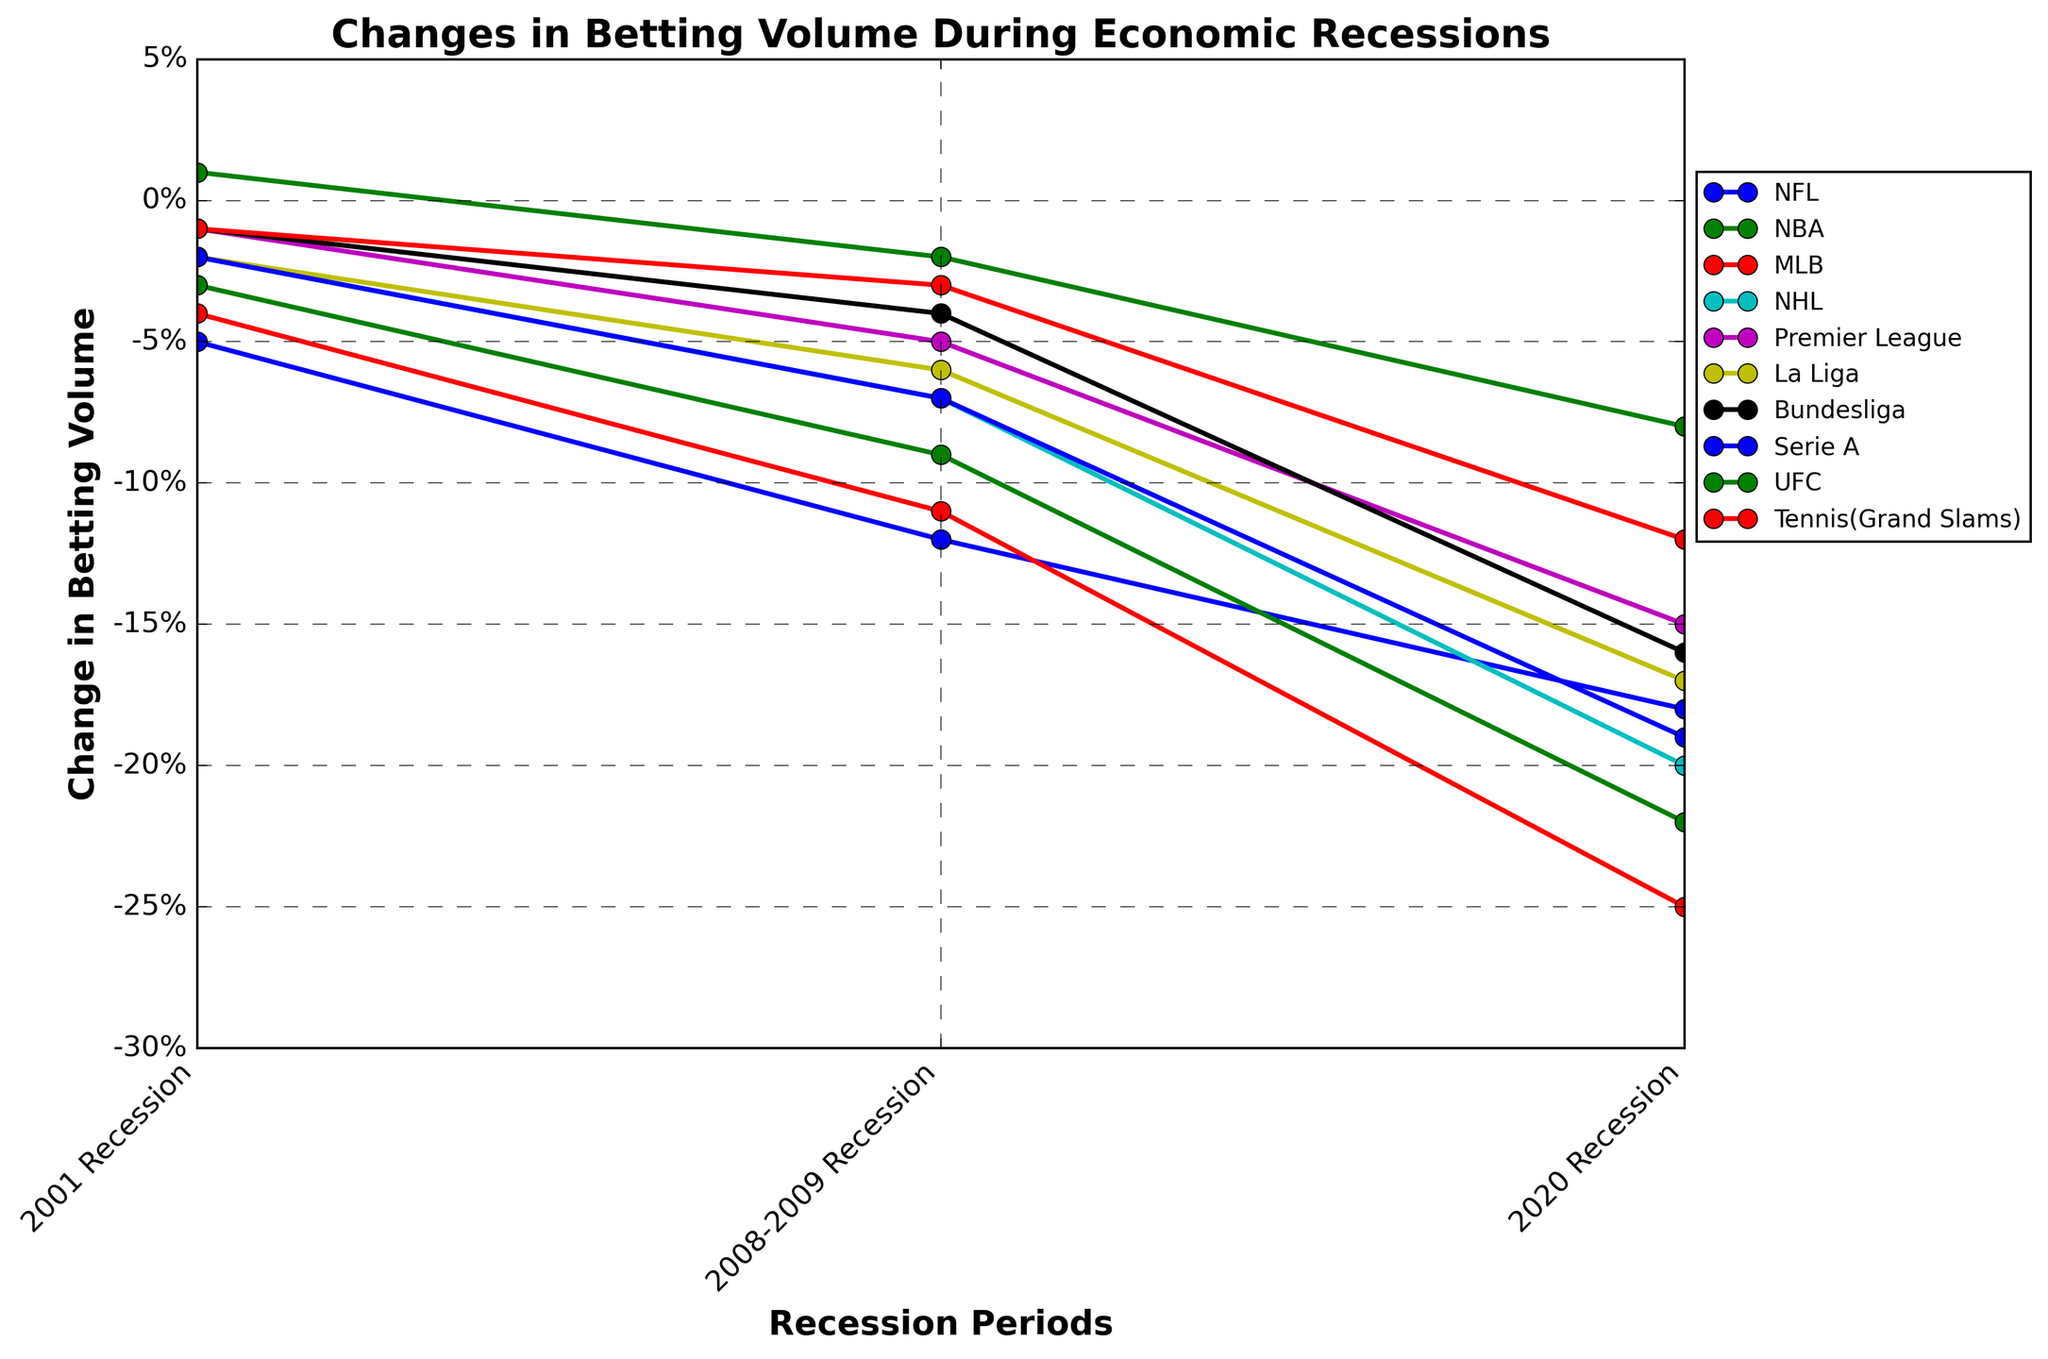Which league shows an increase in betting volume in the 2001 Recession? Examine the values plotted for each league at the point labeled '2001 Recession'. Only the UFC has a positive change (+1%) while all other leagues have a negative change.
Answer: UFC Comparing the NFL and NBA, which league experienced a larger decline in betting volume during the 2020 Recession? Look at the plotted lines for the NFL and NBA at the '2020 Recession' point. The NFL shows a decline of -18%, while the NBA shows a larger decline of -22%. Therefore, the NBA experienced a larger decline.
Answer: NBA How does the change in betting volume for Serie A in the 2020 Recession compare to the change during the 2001 Recession? The plot shows Serie A’s change in betting volume as -2% in the 2001 Recession and -19% in the 2020 Recession. The 2020 Recession represents a larger decline.
Answer: Larger decline in 2020 Which recession period shows the least impact on betting volume for the Premier League? Observe the Premier League line over the three recession periods. The smallest decline is during the 2001 Recession at -1%.
Answer: 2001 Recession Calculate the average change in betting volume for all leagues during the 2008-2009 Recession. The changes in the 2008-2009 Recession for the listed leagues are: NFL (-12%), NBA (-9%), MLB (-11%), NHL (-7%), Premier League (-5%), La Liga (-6%), Bundesliga (-4%), Serie A (-7%), UFC (-2%), Tennis (Grand Slams) (-3%). The average is calculated as: \((-12 - 9 - 11 - 7 - 5 - 6 - 4 - 7 - 2 - 3) / 10 = -6.6\%\).
Answer: -6.6% Which leagues experienced over a 20% decline in betting volume during the 2020 Recession? Examine each league’s change at the '2020 Recession' point. NBA (-22%), MLB (-25%), and NHL (-20%) have declines over 20%.
Answer: NBA, MLB, NHL Is the change in betting volume for the UFC consistent across the three recessions? Review the plotted line for UFC across the three recession periods. Changes are: +1% in 2001, -2% in 2008-2009, and -8% in 2020, showing inconsistency.
Answer: No Which league had the smallest decline in betting volume during the 2020 Recession? Check the values at the '2020 Recession' point. Premier League has the smallest decline with -15%.
Answer: Premier League 